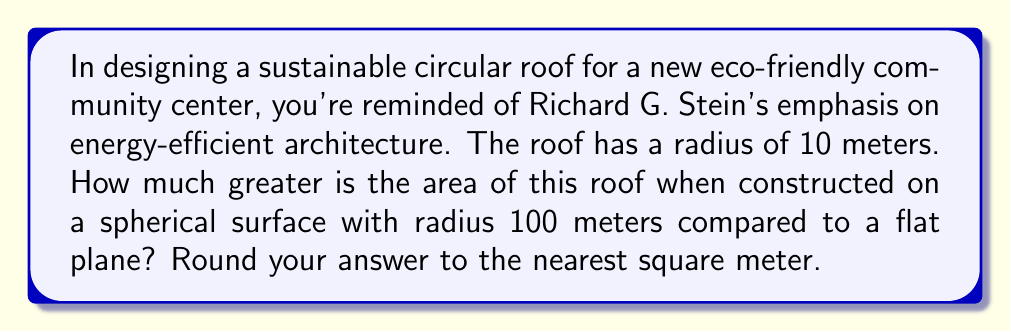Could you help me with this problem? Let's approach this step-by-step:

1) First, let's calculate the area of the circle on a flat plane:
   $$A_{flat} = \pi r^2 = \pi (10\,\text{m})^2 = 100\pi\,\text{m}^2$$

2) Now, for the area on a sphere, we need to use the formula for the area of a spherical cap:
   $$A_{sphere} = 2\pi Rh$$
   where $R$ is the radius of the sphere and $h$ is the height of the cap.

3) To find $h$, we can use the Pythagorean theorem:
   $$R^2 = (R-h)^2 + r^2$$
   $$(100\,\text{m})^2 = (100\,\text{m}-h)^2 + (10\,\text{m})^2$$
   $$10000 = 10000 - 200h + h^2 + 100$$
   $$h^2 - 200h + 100 = 0$$

4) Solving this quadratic equation:
   $$h \approx 0.5025\,\text{m}$$

5) Now we can calculate the area on the sphere:
   $$A_{sphere} = 2\pi Rh = 2\pi (100\,\text{m})(0.5025\,\text{m}) = 100.5\pi\,\text{m}^2$$

6) The difference in area is:
   $$A_{sphere} - A_{flat} = 100.5\pi\,\text{m}^2 - 100\pi\,\text{m}^2 = 0.5\pi\,\text{m}^2 \approx 1.57\,\text{m}^2$$

7) Rounding to the nearest square meter:
   $$1.57\,\text{m}^2 \approx 2\,\text{m}^2$$

[asy]
import geometry;

size(200);

pair O = (0,0);
real R = 100;
real r = 10;
real h = 0.5025;

draw(Circle(O, R), gray);
draw(Arc(O, r, -90, 90), red+1);
draw((-r,0)--(r,0), red+1);
draw(O--(0,R), dashed);
draw(O--(r,0), dashed);
draw((0,R-h)--(r,0), dashed);

label("R", (0,R/2), E);
label("r", (r/2,0), S);
label("h", (r/2,R-h/2), NW);

dot("O", O, SW);
[/asy]
Answer: 2 m² 